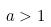<formula> <loc_0><loc_0><loc_500><loc_500>a > 1</formula> 